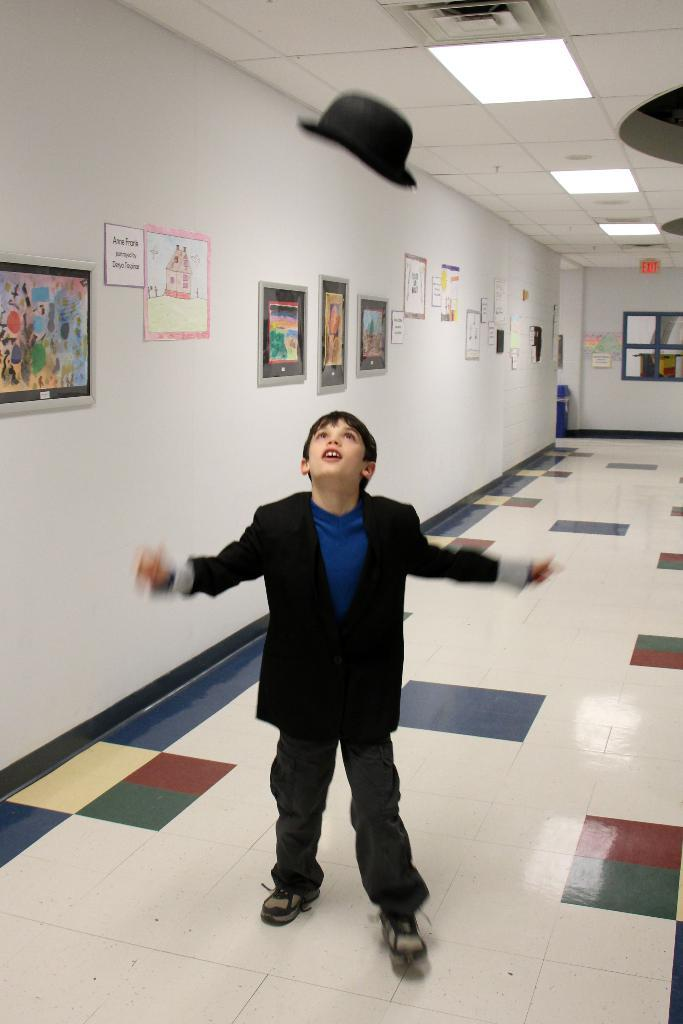What is the main subject of the image? The main subject of the image is a boy standing on the floor. What can be seen on the walls in the image? There are photo frames and posters on the wall. What is visible at the top of the roof in the image? There are lights visible at the top of the roof. What accessory is present in the image? There is a hat in the image. How does the scarecrow wish for rain in the image? There is no scarecrow or mention of rain in the image; it features a boy standing on the floor with various items on the walls and a hat. 